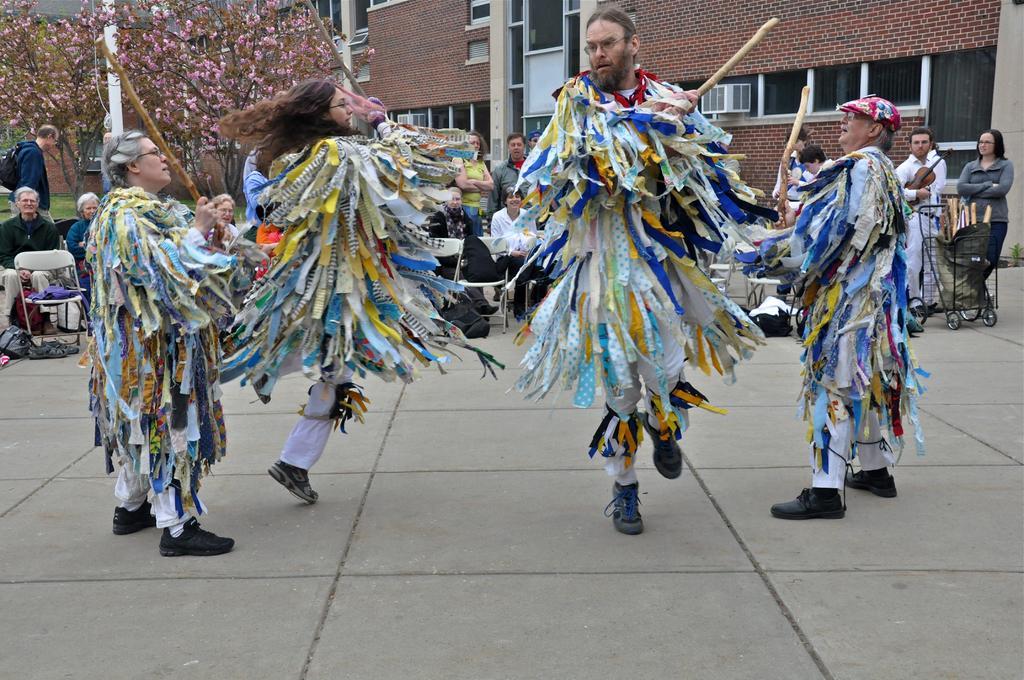Describe this image in one or two sentences. In this image there are a few people in different costumes are dancing by holding a wooden sticks in their hands, behind them there are a few spectators and there are a few objects. In the background there are trees and buildings. 